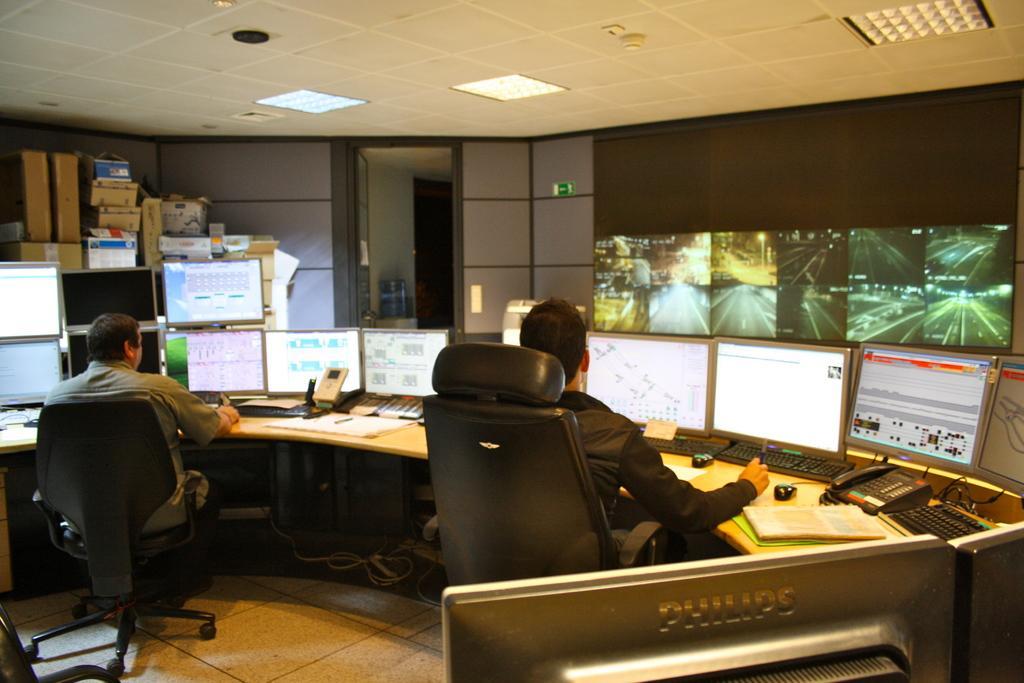In one or two sentences, can you explain what this image depicts? A picture inside of a room. On this table are monitors, keyboards, mouses, books and telephone. A screen on wall. These are cardboard boxes. These 2 persons are sitting on chair. 